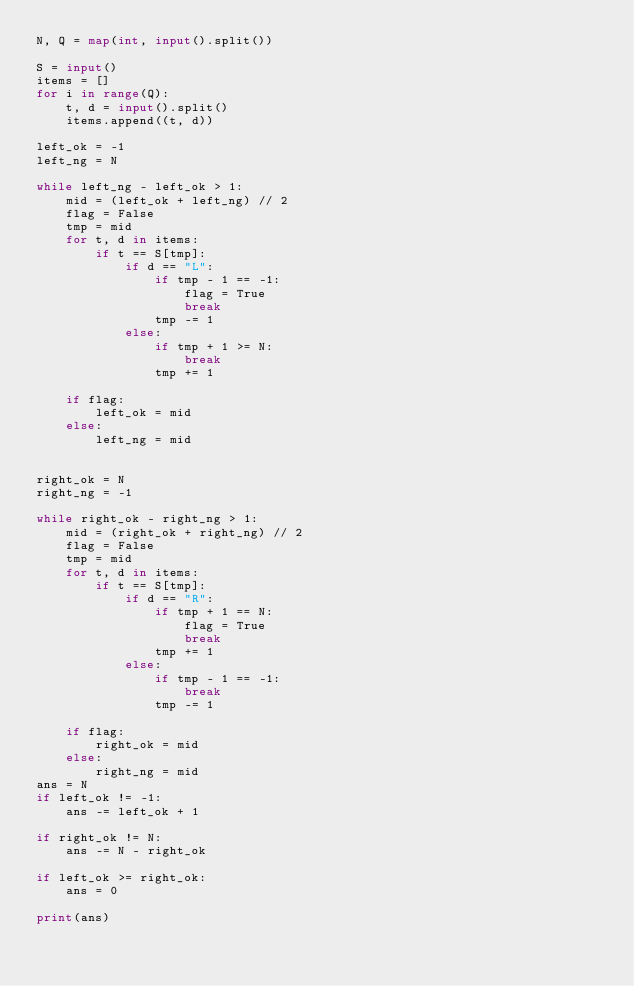<code> <loc_0><loc_0><loc_500><loc_500><_Python_>N, Q = map(int, input().split())

S = input()
items = []
for i in range(Q):
    t, d = input().split()
    items.append((t, d))

left_ok = -1
left_ng = N

while left_ng - left_ok > 1:
    mid = (left_ok + left_ng) // 2
    flag = False
    tmp = mid
    for t, d in items:
        if t == S[tmp]:
            if d == "L":
                if tmp - 1 == -1:
                    flag = True
                    break
                tmp -= 1
            else:
                if tmp + 1 >= N:
                    break
                tmp += 1

    if flag:
        left_ok = mid
    else:
        left_ng = mid


right_ok = N
right_ng = -1

while right_ok - right_ng > 1:
    mid = (right_ok + right_ng) // 2
    flag = False
    tmp = mid
    for t, d in items:
        if t == S[tmp]:
            if d == "R":
                if tmp + 1 == N:
                    flag = True
                    break
                tmp += 1
            else:
                if tmp - 1 == -1:
                    break
                tmp -= 1

    if flag:
        right_ok = mid
    else:
        right_ng = mid
ans = N
if left_ok != -1:
    ans -= left_ok + 1

if right_ok != N:
    ans -= N - right_ok

if left_ok >= right_ok:
    ans = 0

print(ans)
</code> 